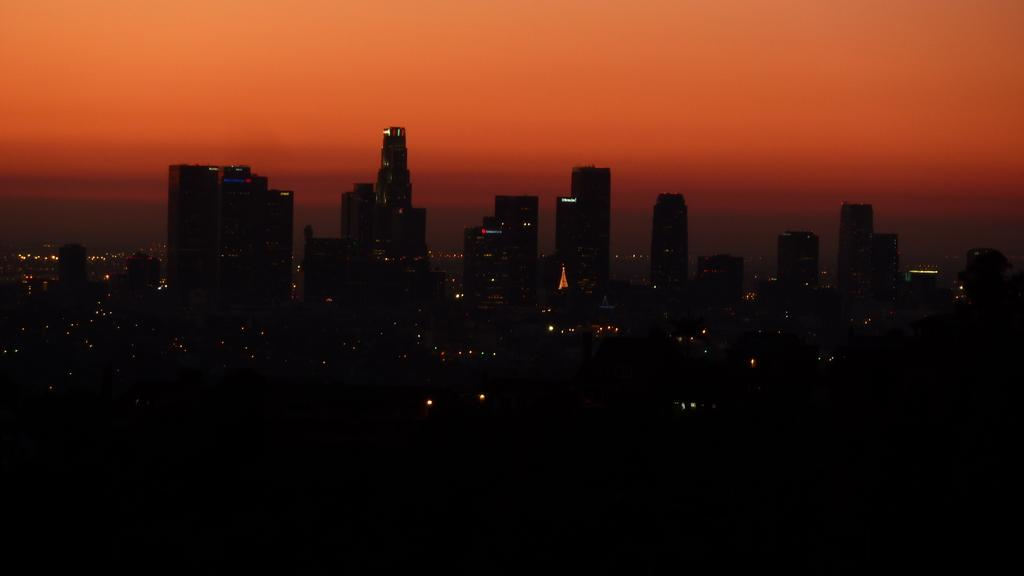What structures are present in the image? There are buildings in the image. What part of the natural environment is visible in the image? The sky is visible at the top of the image. How many bubbles can be seen floating around the buildings in the image? There are no bubbles present in the image; it features buildings and the sky. What type of stone is used to construct the buildings in the image? The image does not provide information about the materials used to construct the buildings, so it cannot be determined from the image. 